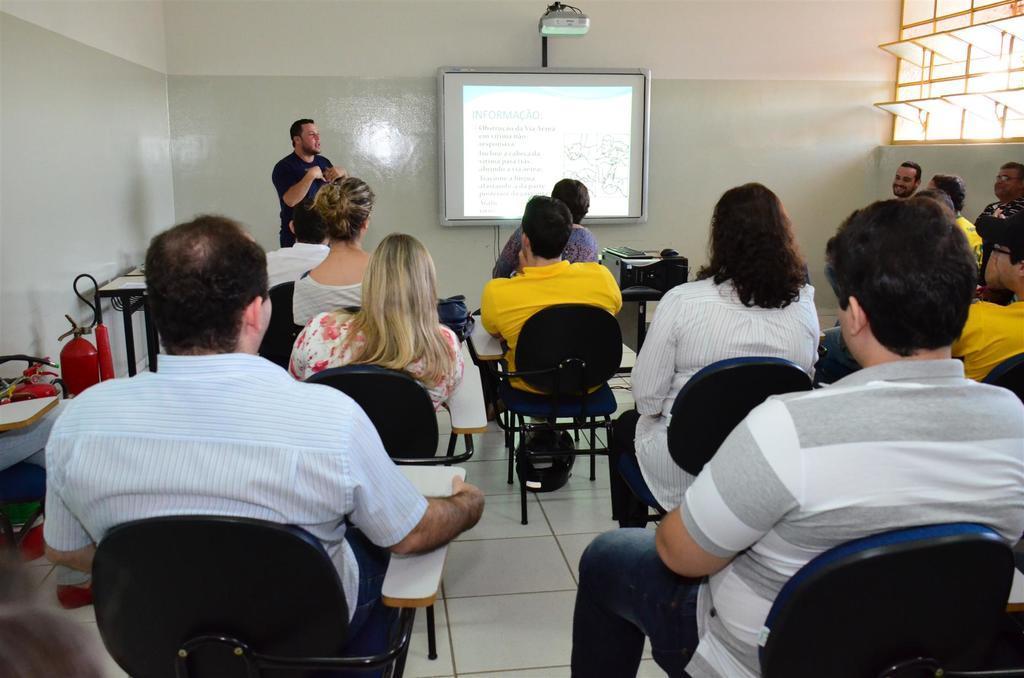Could you give a brief overview of what you see in this image? The picture is taken in a closed room where number of people sitting on the chairs and at the left corner of the picture one person is standing in a black dress beside him there is one screen in front of the screen there is a table and at the right corner of the picture there are windows opened and in the left corner of the picture there is a fire extinguisher and some things. 